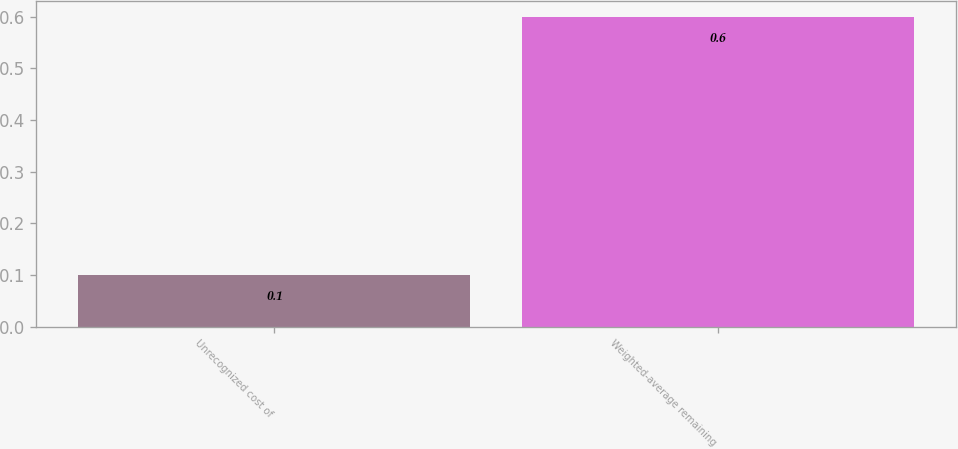Convert chart to OTSL. <chart><loc_0><loc_0><loc_500><loc_500><bar_chart><fcel>Unrecognized cost of<fcel>Weighted-average remaining<nl><fcel>0.1<fcel>0.6<nl></chart> 